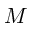<formula> <loc_0><loc_0><loc_500><loc_500>M</formula> 